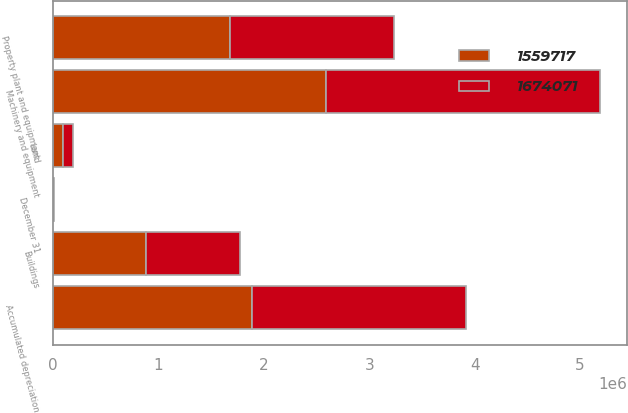<chart> <loc_0><loc_0><loc_500><loc_500><stacked_bar_chart><ecel><fcel>December 31<fcel>Land<fcel>Buildings<fcel>Machinery and equipment<fcel>Property plant and equipment<fcel>Accumulated depreciation<nl><fcel>1.55972e+06<fcel>2012<fcel>92916<fcel>878527<fcel>2.58918e+06<fcel>1.67407e+06<fcel>1.88656e+06<nl><fcel>1.67407e+06<fcel>2011<fcel>92495<fcel>895859<fcel>2.6002e+06<fcel>1.55972e+06<fcel>2.02884e+06<nl></chart> 